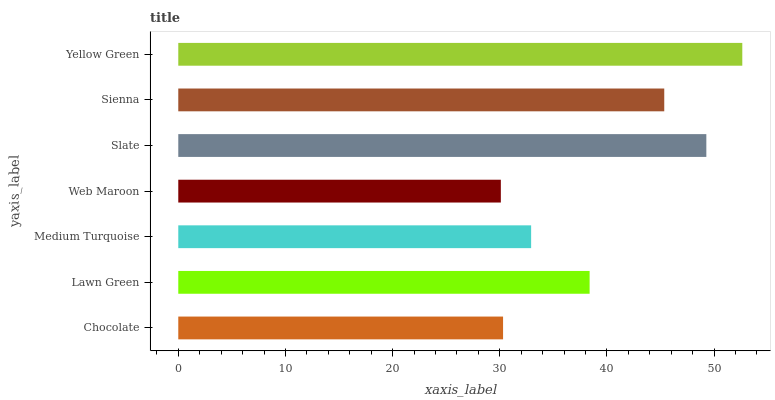Is Web Maroon the minimum?
Answer yes or no. Yes. Is Yellow Green the maximum?
Answer yes or no. Yes. Is Lawn Green the minimum?
Answer yes or no. No. Is Lawn Green the maximum?
Answer yes or no. No. Is Lawn Green greater than Chocolate?
Answer yes or no. Yes. Is Chocolate less than Lawn Green?
Answer yes or no. Yes. Is Chocolate greater than Lawn Green?
Answer yes or no. No. Is Lawn Green less than Chocolate?
Answer yes or no. No. Is Lawn Green the high median?
Answer yes or no. Yes. Is Lawn Green the low median?
Answer yes or no. Yes. Is Yellow Green the high median?
Answer yes or no. No. Is Slate the low median?
Answer yes or no. No. 